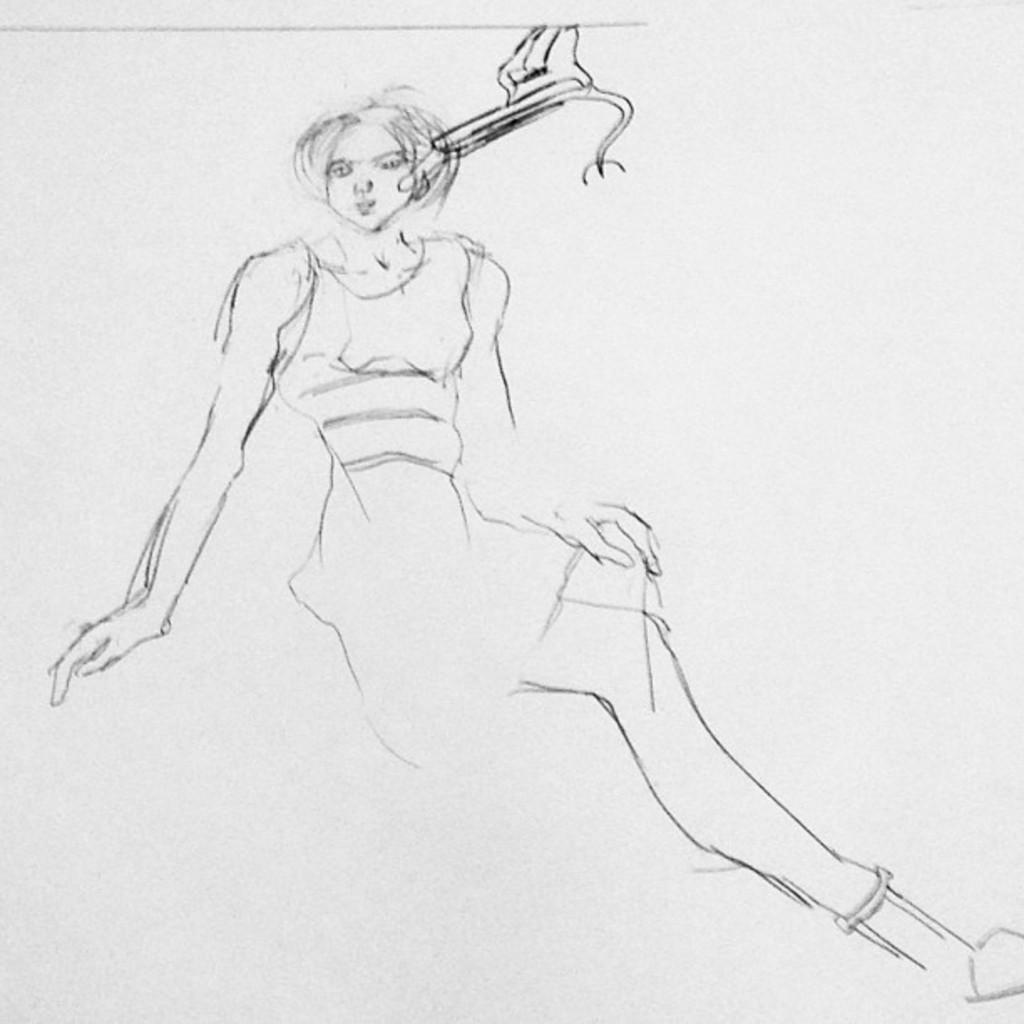In one or two sentences, can you explain what this image depicts? This image consists of a paper with a sketch of a woman in the middle of the image. 